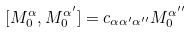<formula> <loc_0><loc_0><loc_500><loc_500>[ M _ { 0 } ^ { \alpha } , M _ { 0 } ^ { \alpha ^ { \prime } } ] = c _ { \alpha \alpha ^ { \prime } \alpha ^ { \prime \prime } } M _ { 0 } ^ { \alpha ^ { \prime \prime } }</formula> 